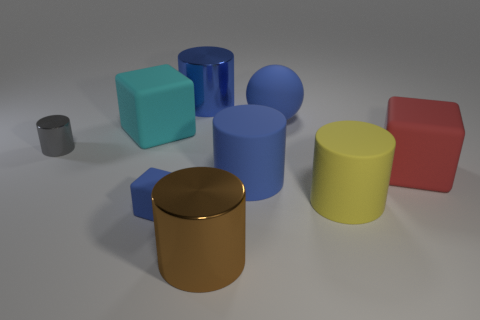What size is the gray cylinder that is made of the same material as the brown object?
Your response must be concise. Small. What number of cyan things are either big cylinders or large objects?
Provide a short and direct response. 1. There is a metal object that is the same color as the tiny cube; what is its shape?
Keep it short and to the point. Cylinder. Is there any other thing that is the same material as the large blue ball?
Give a very brief answer. Yes. There is a large metallic thing behind the yellow cylinder; does it have the same shape as the big blue matte thing behind the small metallic thing?
Offer a terse response. No. What number of large balls are there?
Keep it short and to the point. 1. What is the shape of the red object that is made of the same material as the small block?
Your response must be concise. Cube. Is there any other thing of the same color as the large rubber sphere?
Keep it short and to the point. Yes. Is the color of the tiny shiny cylinder the same as the cylinder in front of the yellow object?
Your answer should be very brief. No. Are there fewer cyan matte objects in front of the small rubber object than red rubber objects?
Offer a terse response. Yes. 